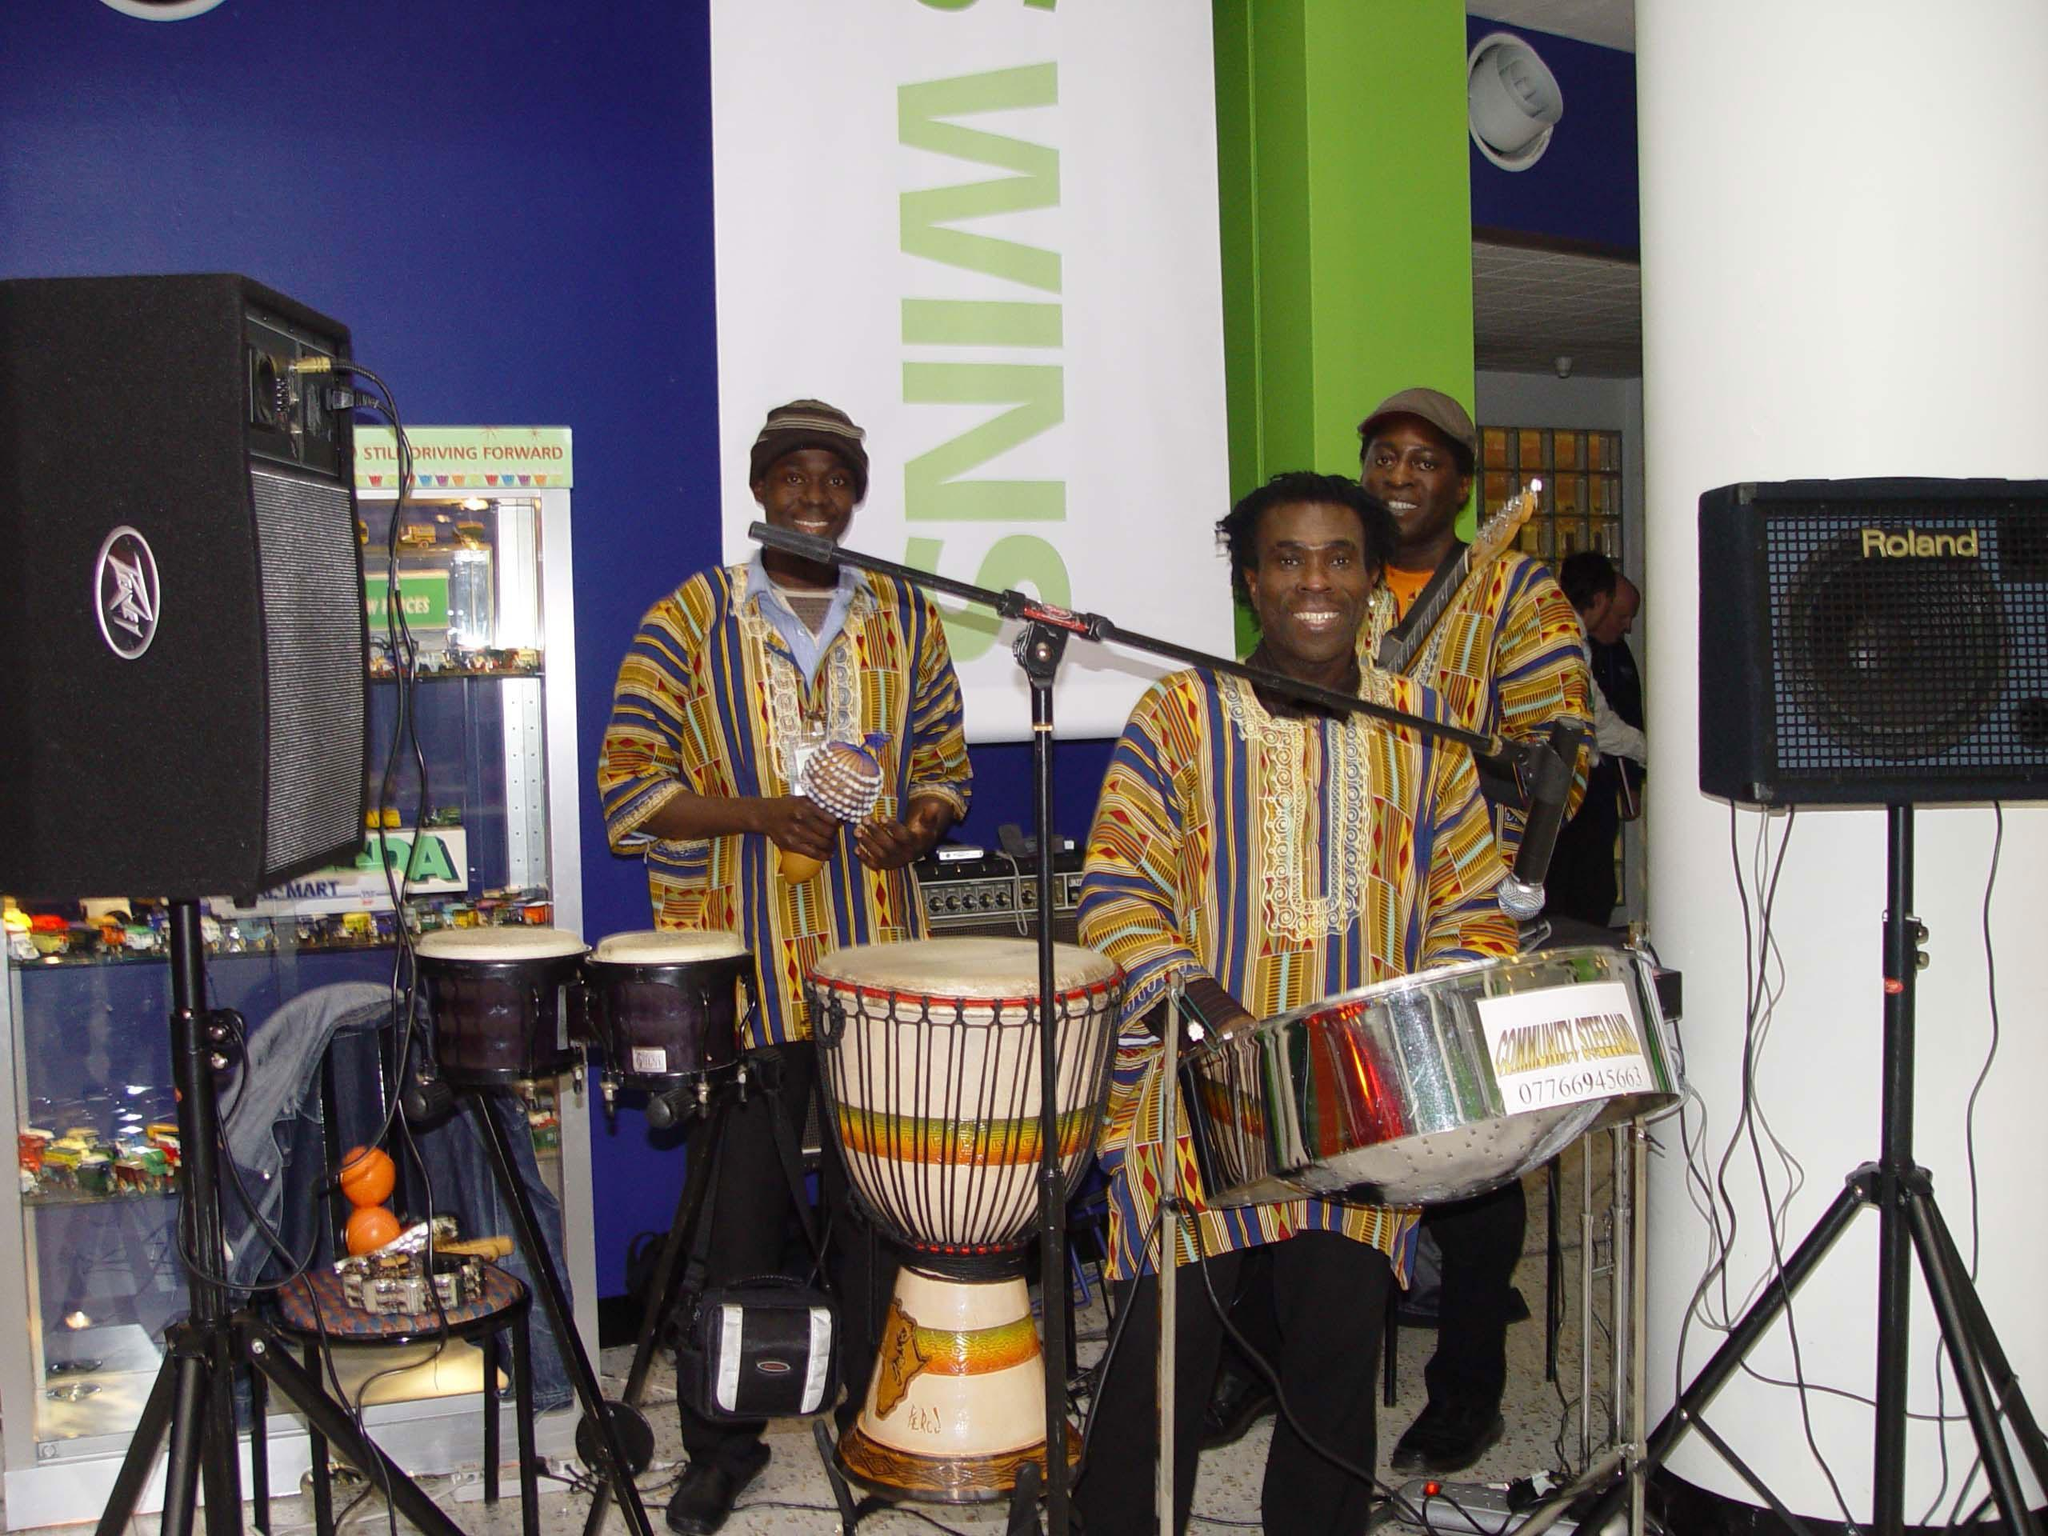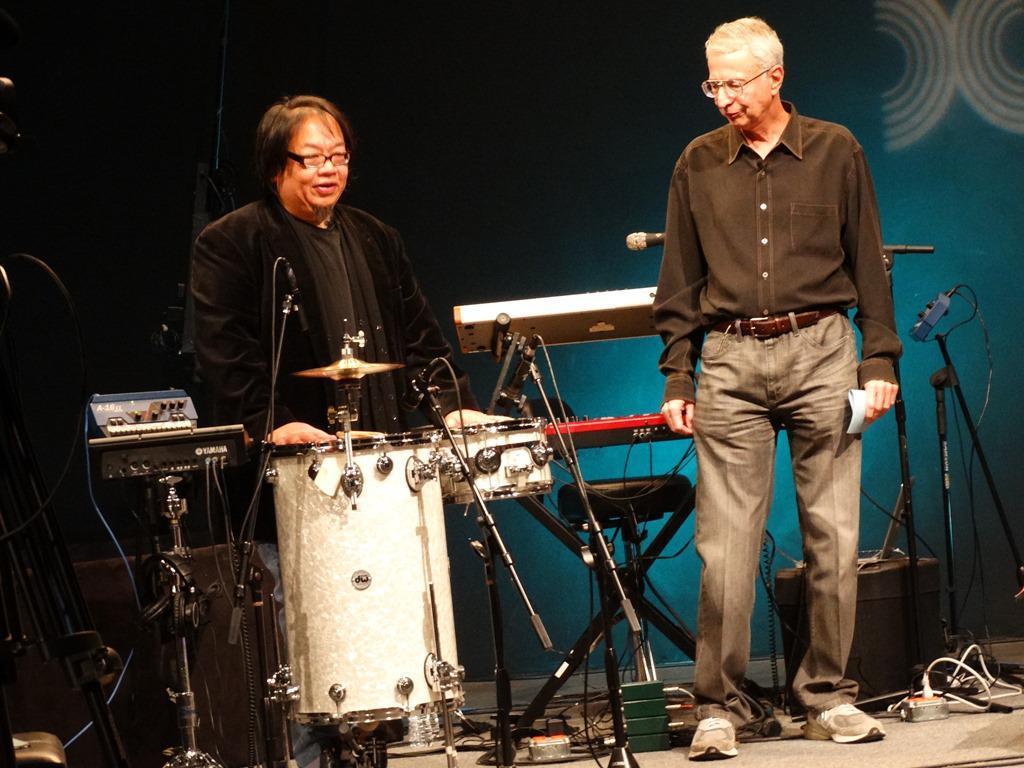The first image is the image on the left, the second image is the image on the right. Given the left and right images, does the statement "There are three men standing next to each-other in the image on the left." hold true? Answer yes or no. Yes. The first image is the image on the left, the second image is the image on the right. Analyze the images presented: Is the assertion "One drummer is wearing a floral print shirt." valid? Answer yes or no. No. 